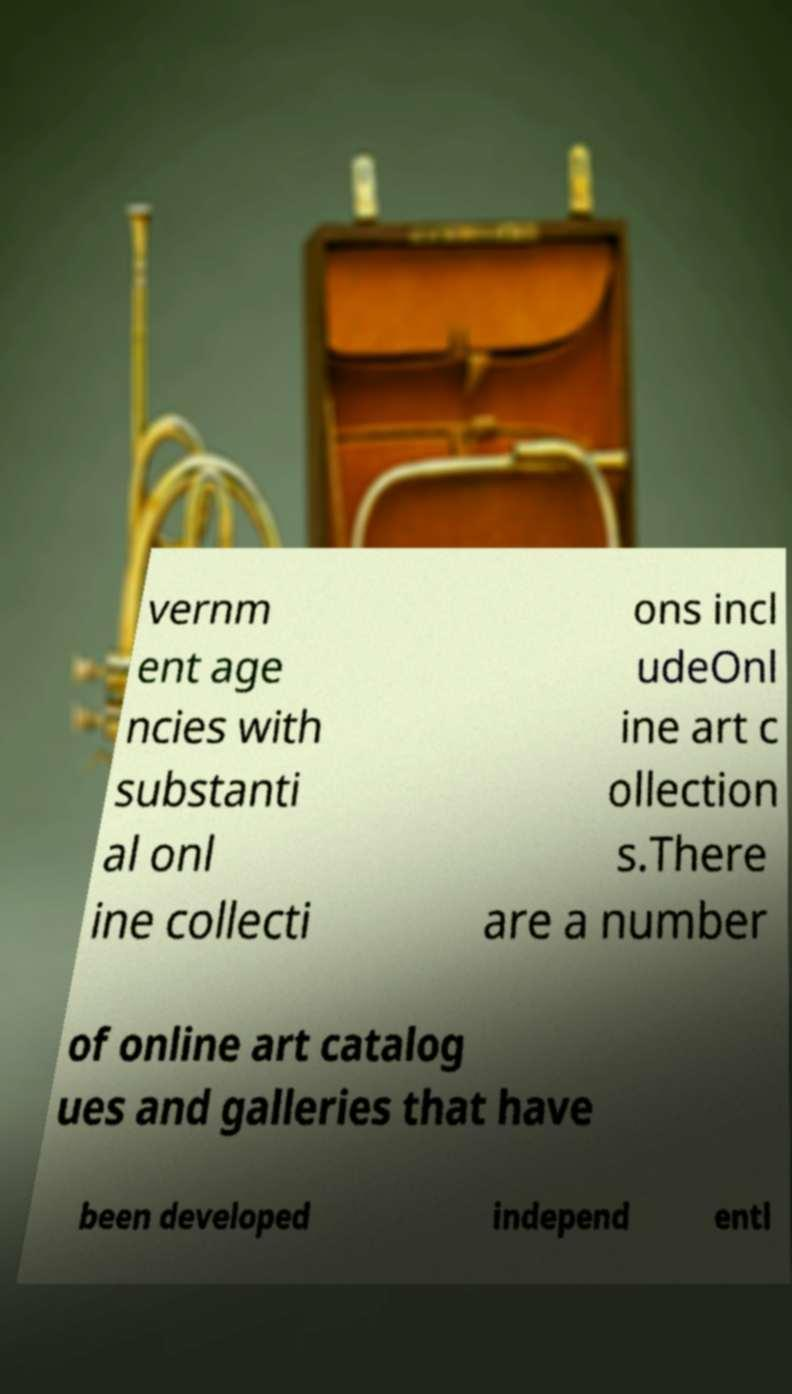Please identify and transcribe the text found in this image. vernm ent age ncies with substanti al onl ine collecti ons incl udeOnl ine art c ollection s.There are a number of online art catalog ues and galleries that have been developed independ entl 